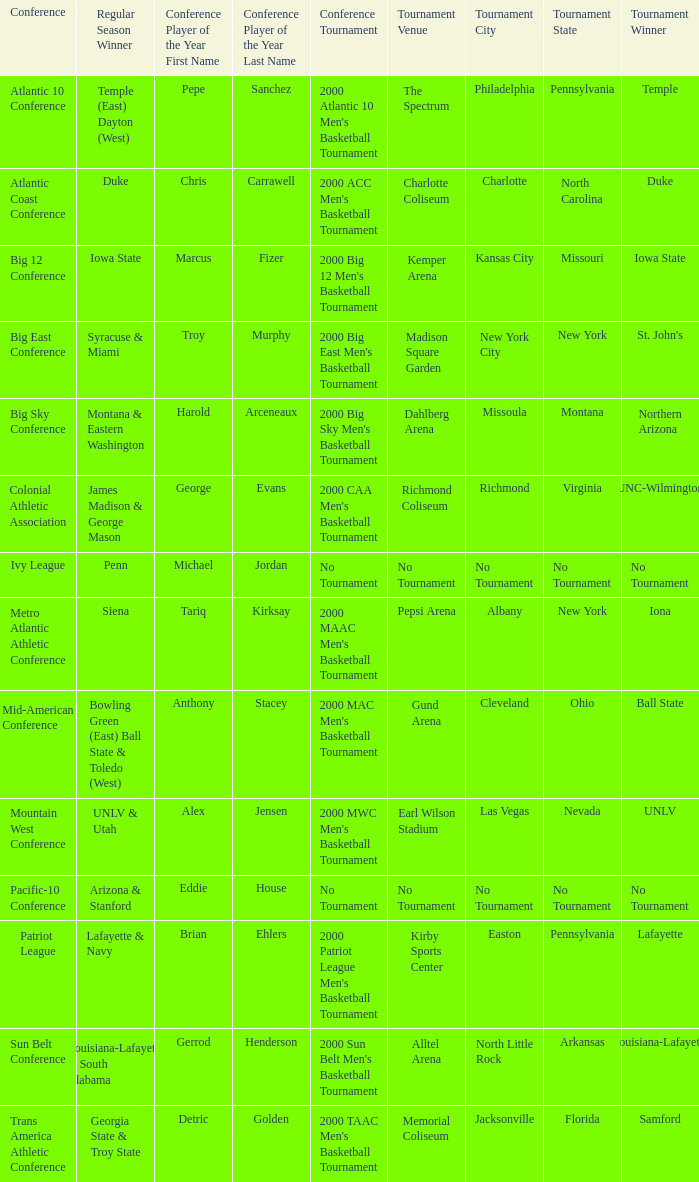What is the location and municipality where the 2000 mwc men's basketball tournament? Earl Wilson Stadium ( Las Vegas, Nevada ). 